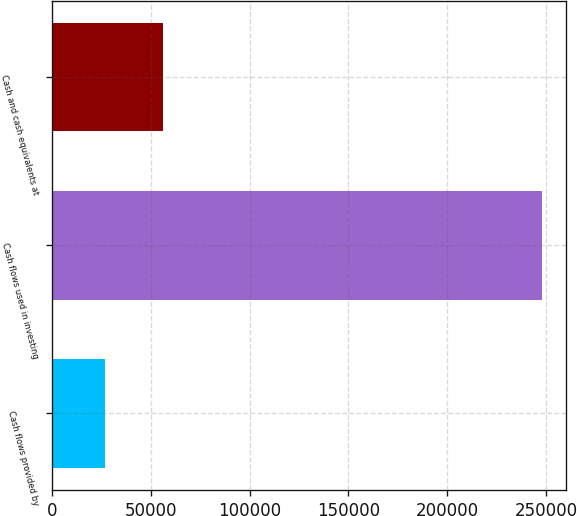Convert chart. <chart><loc_0><loc_0><loc_500><loc_500><bar_chart><fcel>Cash flows provided by<fcel>Cash flows used in investing<fcel>Cash and cash equivalents at<nl><fcel>27098<fcel>247757<fcel>56292<nl></chart> 